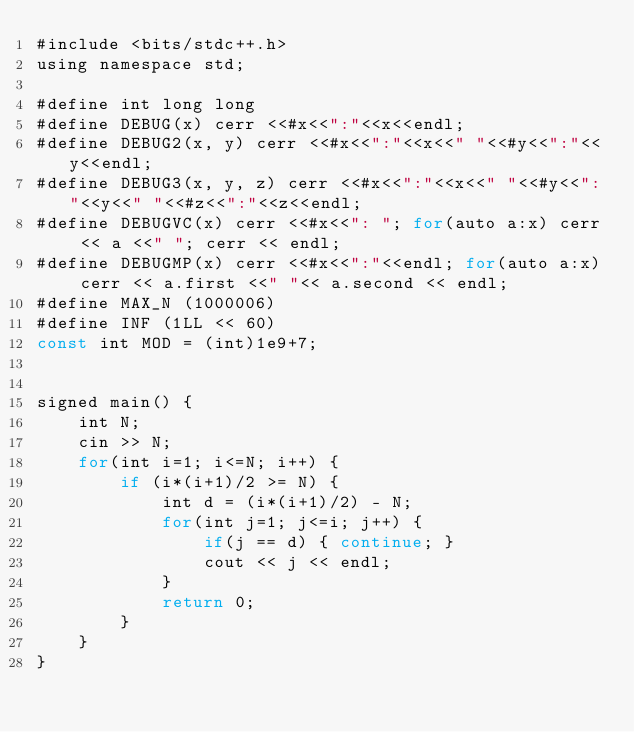<code> <loc_0><loc_0><loc_500><loc_500><_Rust_>#include <bits/stdc++.h>
using namespace std;

#define int long long
#define DEBUG(x) cerr <<#x<<":"<<x<<endl;
#define DEBUG2(x, y) cerr <<#x<<":"<<x<<" "<<#y<<":"<<y<<endl;
#define DEBUG3(x, y, z) cerr <<#x<<":"<<x<<" "<<#y<<":"<<y<<" "<<#z<<":"<<z<<endl;
#define DEBUGVC(x) cerr <<#x<<": "; for(auto a:x) cerr << a <<" "; cerr << endl;
#define DEBUGMP(x) cerr <<#x<<":"<<endl; for(auto a:x) cerr << a.first <<" "<< a.second << endl;
#define MAX_N (1000006)
#define INF (1LL << 60)
const int MOD = (int)1e9+7;


signed main() {
    int N;
    cin >> N;
    for(int i=1; i<=N; i++) {
        if (i*(i+1)/2 >= N) {
            int d = (i*(i+1)/2) - N;
            for(int j=1; j<=i; j++) {
                if(j == d) { continue; }
                cout << j << endl;
            }
            return 0;
        }
    }
}
</code> 